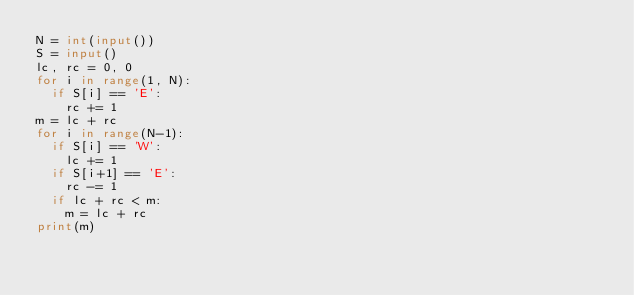<code> <loc_0><loc_0><loc_500><loc_500><_Python_>N = int(input())
S = input()
lc, rc = 0, 0
for i in range(1, N):
  if S[i] == 'E':
    rc += 1
m = lc + rc
for i in range(N-1):
  if S[i] == 'W':
    lc += 1
  if S[i+1] == 'E':
    rc -= 1
  if lc + rc < m:
    m = lc + rc
print(m)</code> 